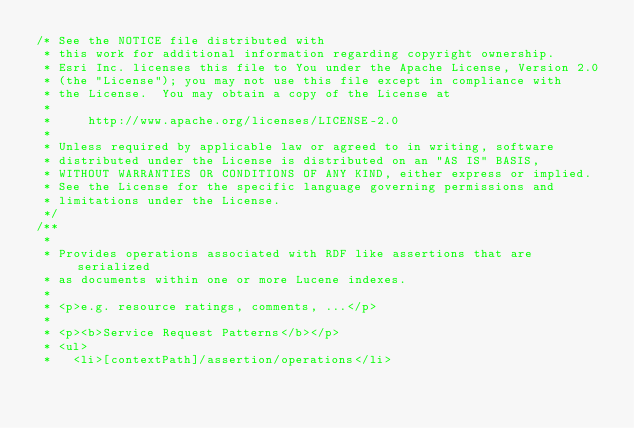<code> <loc_0><loc_0><loc_500><loc_500><_Java_>/* See the NOTICE file distributed with
 * this work for additional information regarding copyright ownership.
 * Esri Inc. licenses this file to You under the Apache License, Version 2.0
 * (the "License"); you may not use this file except in compliance with
 * the License.  You may obtain a copy of the License at
 *
 *     http://www.apache.org/licenses/LICENSE-2.0
 *
 * Unless required by applicable law or agreed to in writing, software
 * distributed under the License is distributed on an "AS IS" BASIS,
 * WITHOUT WARRANTIES OR CONDITIONS OF ANY KIND, either express or implied.
 * See the License for the specific language governing permissions and
 * limitations under the License.
 */
/**
 * 
 * Provides operations associated with RDF like assertions that are serialized
 * as documents within one or more Lucene indexes.
 * 
 * <p>e.g. resource ratings, comments, ...</p> 
 *
 * <p><b>Service Request Patterns</b></p>
 * <ul>
 *   <li>[contextPath]/assertion/operations</li></code> 